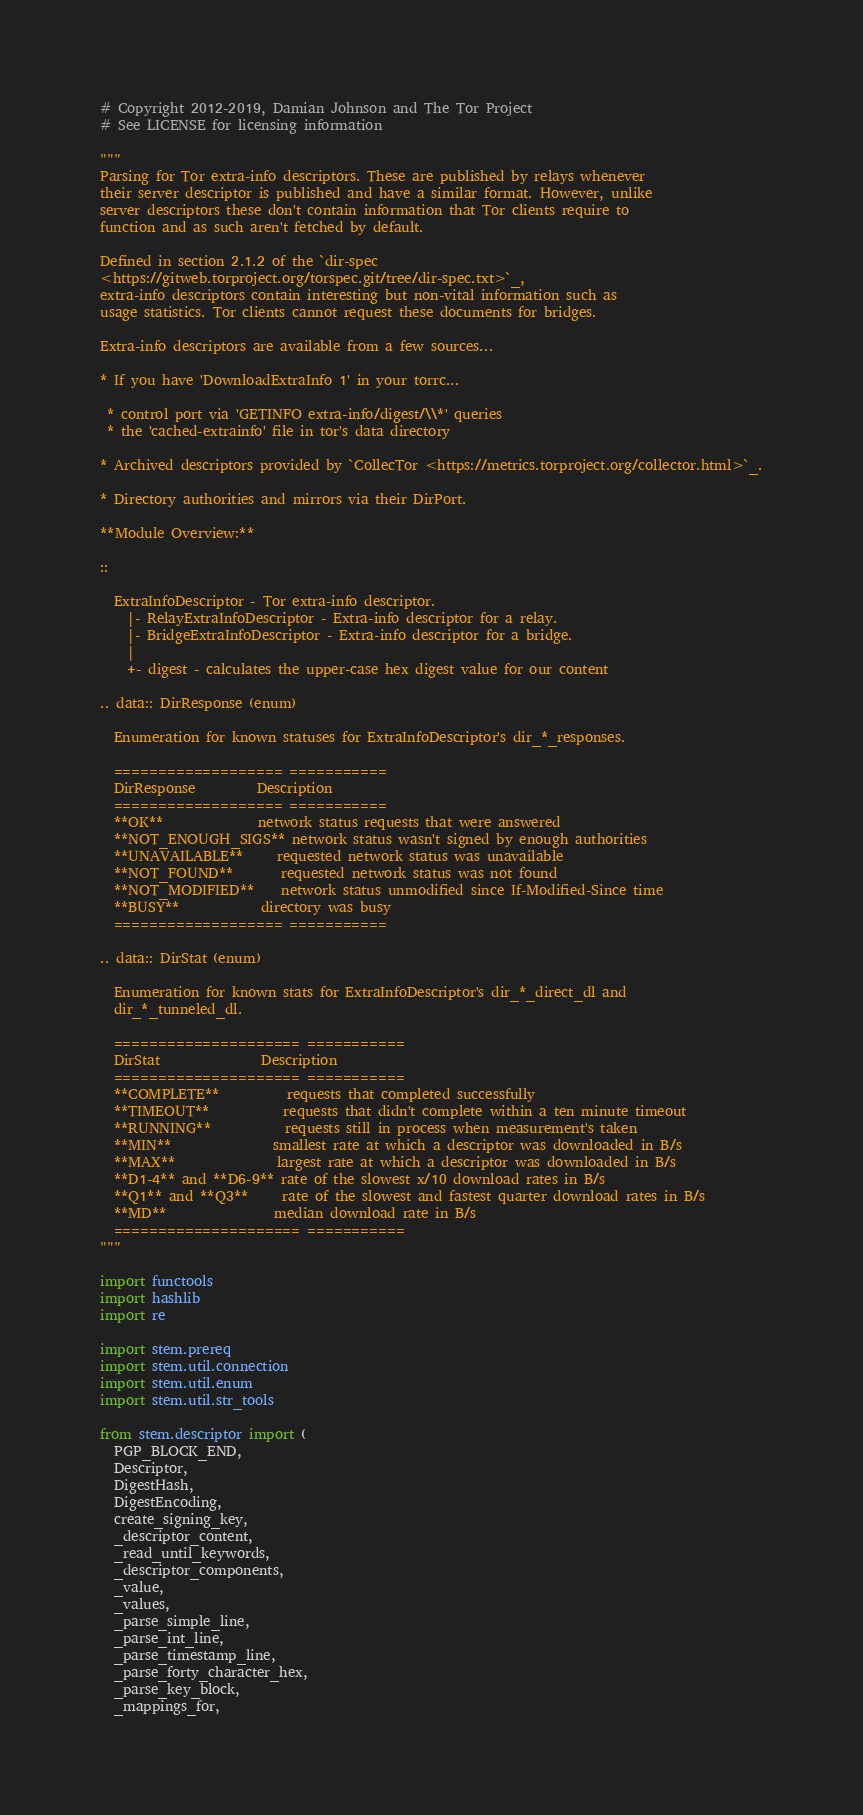Convert code to text. <code><loc_0><loc_0><loc_500><loc_500><_Python_># Copyright 2012-2019, Damian Johnson and The Tor Project
# See LICENSE for licensing information

"""
Parsing for Tor extra-info descriptors. These are published by relays whenever
their server descriptor is published and have a similar format. However, unlike
server descriptors these don't contain information that Tor clients require to
function and as such aren't fetched by default.

Defined in section 2.1.2 of the `dir-spec
<https://gitweb.torproject.org/torspec.git/tree/dir-spec.txt>`_,
extra-info descriptors contain interesting but non-vital information such as
usage statistics. Tor clients cannot request these documents for bridges.

Extra-info descriptors are available from a few sources...

* If you have 'DownloadExtraInfo 1' in your torrc...

 * control port via 'GETINFO extra-info/digest/\\*' queries
 * the 'cached-extrainfo' file in tor's data directory

* Archived descriptors provided by `CollecTor <https://metrics.torproject.org/collector.html>`_.

* Directory authorities and mirrors via their DirPort.

**Module Overview:**

::

  ExtraInfoDescriptor - Tor extra-info descriptor.
    |- RelayExtraInfoDescriptor - Extra-info descriptor for a relay.
    |- BridgeExtraInfoDescriptor - Extra-info descriptor for a bridge.
    |
    +- digest - calculates the upper-case hex digest value for our content

.. data:: DirResponse (enum)

  Enumeration for known statuses for ExtraInfoDescriptor's dir_*_responses.

  =================== ===========
  DirResponse         Description
  =================== ===========
  **OK**              network status requests that were answered
  **NOT_ENOUGH_SIGS** network status wasn't signed by enough authorities
  **UNAVAILABLE**     requested network status was unavailable
  **NOT_FOUND**       requested network status was not found
  **NOT_MODIFIED**    network status unmodified since If-Modified-Since time
  **BUSY**            directory was busy
  =================== ===========

.. data:: DirStat (enum)

  Enumeration for known stats for ExtraInfoDescriptor's dir_*_direct_dl and
  dir_*_tunneled_dl.

  ===================== ===========
  DirStat               Description
  ===================== ===========
  **COMPLETE**          requests that completed successfully
  **TIMEOUT**           requests that didn't complete within a ten minute timeout
  **RUNNING**           requests still in process when measurement's taken
  **MIN**               smallest rate at which a descriptor was downloaded in B/s
  **MAX**               largest rate at which a descriptor was downloaded in B/s
  **D1-4** and **D6-9** rate of the slowest x/10 download rates in B/s
  **Q1** and **Q3**     rate of the slowest and fastest quarter download rates in B/s
  **MD**                median download rate in B/s
  ===================== ===========
"""

import functools
import hashlib
import re

import stem.prereq
import stem.util.connection
import stem.util.enum
import stem.util.str_tools

from stem.descriptor import (
  PGP_BLOCK_END,
  Descriptor,
  DigestHash,
  DigestEncoding,
  create_signing_key,
  _descriptor_content,
  _read_until_keywords,
  _descriptor_components,
  _value,
  _values,
  _parse_simple_line,
  _parse_int_line,
  _parse_timestamp_line,
  _parse_forty_character_hex,
  _parse_key_block,
  _mappings_for,</code> 